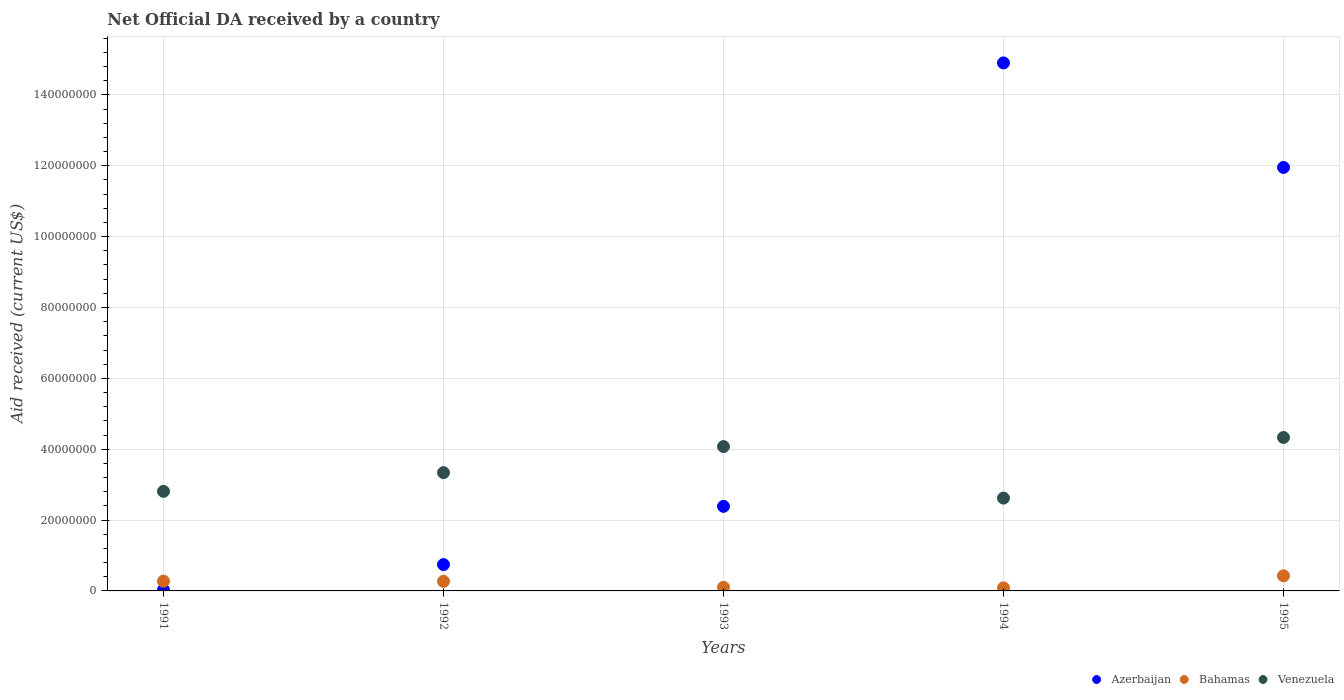How many different coloured dotlines are there?
Your answer should be very brief. 3. What is the net official development assistance aid received in Venezuela in 1992?
Make the answer very short. 3.34e+07. Across all years, what is the maximum net official development assistance aid received in Bahamas?
Offer a terse response. 4.26e+06. Across all years, what is the minimum net official development assistance aid received in Bahamas?
Keep it short and to the point. 8.70e+05. In which year was the net official development assistance aid received in Azerbaijan minimum?
Make the answer very short. 1991. What is the total net official development assistance aid received in Venezuela in the graph?
Make the answer very short. 1.72e+08. What is the difference between the net official development assistance aid received in Bahamas in 1992 and that in 1995?
Ensure brevity in your answer.  -1.56e+06. What is the difference between the net official development assistance aid received in Azerbaijan in 1991 and the net official development assistance aid received in Bahamas in 1992?
Give a very brief answer. -2.40e+06. What is the average net official development assistance aid received in Azerbaijan per year?
Make the answer very short. 6.00e+07. In the year 1994, what is the difference between the net official development assistance aid received in Bahamas and net official development assistance aid received in Azerbaijan?
Provide a short and direct response. -1.48e+08. What is the ratio of the net official development assistance aid received in Venezuela in 1992 to that in 1993?
Provide a succinct answer. 0.82. Is the net official development assistance aid received in Bahamas in 1994 less than that in 1995?
Keep it short and to the point. Yes. Is the difference between the net official development assistance aid received in Bahamas in 1993 and 1995 greater than the difference between the net official development assistance aid received in Azerbaijan in 1993 and 1995?
Offer a terse response. Yes. What is the difference between the highest and the second highest net official development assistance aid received in Venezuela?
Keep it short and to the point. 2.57e+06. What is the difference between the highest and the lowest net official development assistance aid received in Bahamas?
Your answer should be very brief. 3.39e+06. In how many years, is the net official development assistance aid received in Azerbaijan greater than the average net official development assistance aid received in Azerbaijan taken over all years?
Offer a terse response. 2. Is the sum of the net official development assistance aid received in Bahamas in 1993 and 1994 greater than the maximum net official development assistance aid received in Venezuela across all years?
Offer a terse response. No. Is it the case that in every year, the sum of the net official development assistance aid received in Azerbaijan and net official development assistance aid received in Bahamas  is greater than the net official development assistance aid received in Venezuela?
Offer a terse response. No. Is the net official development assistance aid received in Bahamas strictly less than the net official development assistance aid received in Azerbaijan over the years?
Provide a short and direct response. No. What is the difference between two consecutive major ticks on the Y-axis?
Make the answer very short. 2.00e+07. Does the graph contain any zero values?
Provide a short and direct response. No. Does the graph contain grids?
Your response must be concise. Yes. How are the legend labels stacked?
Keep it short and to the point. Horizontal. What is the title of the graph?
Offer a terse response. Net Official DA received by a country. What is the label or title of the X-axis?
Your response must be concise. Years. What is the label or title of the Y-axis?
Give a very brief answer. Aid received (current US$). What is the Aid received (current US$) in Bahamas in 1991?
Offer a very short reply. 2.76e+06. What is the Aid received (current US$) in Venezuela in 1991?
Provide a succinct answer. 2.81e+07. What is the Aid received (current US$) of Azerbaijan in 1992?
Offer a terse response. 7.43e+06. What is the Aid received (current US$) of Bahamas in 1992?
Your response must be concise. 2.70e+06. What is the Aid received (current US$) of Venezuela in 1992?
Your answer should be very brief. 3.34e+07. What is the Aid received (current US$) in Azerbaijan in 1993?
Provide a short and direct response. 2.39e+07. What is the Aid received (current US$) in Bahamas in 1993?
Your response must be concise. 1.03e+06. What is the Aid received (current US$) of Venezuela in 1993?
Your response must be concise. 4.08e+07. What is the Aid received (current US$) of Azerbaijan in 1994?
Your answer should be compact. 1.49e+08. What is the Aid received (current US$) in Bahamas in 1994?
Provide a succinct answer. 8.70e+05. What is the Aid received (current US$) of Venezuela in 1994?
Offer a very short reply. 2.62e+07. What is the Aid received (current US$) of Azerbaijan in 1995?
Your answer should be very brief. 1.20e+08. What is the Aid received (current US$) of Bahamas in 1995?
Ensure brevity in your answer.  4.26e+06. What is the Aid received (current US$) in Venezuela in 1995?
Your answer should be compact. 4.33e+07. Across all years, what is the maximum Aid received (current US$) in Azerbaijan?
Your answer should be compact. 1.49e+08. Across all years, what is the maximum Aid received (current US$) of Bahamas?
Keep it short and to the point. 4.26e+06. Across all years, what is the maximum Aid received (current US$) in Venezuela?
Your answer should be compact. 4.33e+07. Across all years, what is the minimum Aid received (current US$) of Azerbaijan?
Give a very brief answer. 3.00e+05. Across all years, what is the minimum Aid received (current US$) in Bahamas?
Your answer should be very brief. 8.70e+05. Across all years, what is the minimum Aid received (current US$) in Venezuela?
Provide a short and direct response. 2.62e+07. What is the total Aid received (current US$) in Azerbaijan in the graph?
Your response must be concise. 3.00e+08. What is the total Aid received (current US$) of Bahamas in the graph?
Ensure brevity in your answer.  1.16e+07. What is the total Aid received (current US$) of Venezuela in the graph?
Ensure brevity in your answer.  1.72e+08. What is the difference between the Aid received (current US$) in Azerbaijan in 1991 and that in 1992?
Offer a very short reply. -7.13e+06. What is the difference between the Aid received (current US$) in Venezuela in 1991 and that in 1992?
Ensure brevity in your answer.  -5.28e+06. What is the difference between the Aid received (current US$) of Azerbaijan in 1991 and that in 1993?
Your response must be concise. -2.36e+07. What is the difference between the Aid received (current US$) of Bahamas in 1991 and that in 1993?
Offer a terse response. 1.73e+06. What is the difference between the Aid received (current US$) of Venezuela in 1991 and that in 1993?
Provide a succinct answer. -1.26e+07. What is the difference between the Aid received (current US$) of Azerbaijan in 1991 and that in 1994?
Offer a terse response. -1.49e+08. What is the difference between the Aid received (current US$) of Bahamas in 1991 and that in 1994?
Offer a very short reply. 1.89e+06. What is the difference between the Aid received (current US$) of Venezuela in 1991 and that in 1994?
Offer a very short reply. 1.91e+06. What is the difference between the Aid received (current US$) of Azerbaijan in 1991 and that in 1995?
Your answer should be compact. -1.19e+08. What is the difference between the Aid received (current US$) of Bahamas in 1991 and that in 1995?
Give a very brief answer. -1.50e+06. What is the difference between the Aid received (current US$) in Venezuela in 1991 and that in 1995?
Provide a succinct answer. -1.52e+07. What is the difference between the Aid received (current US$) of Azerbaijan in 1992 and that in 1993?
Your answer should be compact. -1.64e+07. What is the difference between the Aid received (current US$) of Bahamas in 1992 and that in 1993?
Offer a terse response. 1.67e+06. What is the difference between the Aid received (current US$) in Venezuela in 1992 and that in 1993?
Provide a succinct answer. -7.36e+06. What is the difference between the Aid received (current US$) of Azerbaijan in 1992 and that in 1994?
Offer a very short reply. -1.42e+08. What is the difference between the Aid received (current US$) in Bahamas in 1992 and that in 1994?
Your answer should be compact. 1.83e+06. What is the difference between the Aid received (current US$) of Venezuela in 1992 and that in 1994?
Offer a very short reply. 7.19e+06. What is the difference between the Aid received (current US$) in Azerbaijan in 1992 and that in 1995?
Ensure brevity in your answer.  -1.12e+08. What is the difference between the Aid received (current US$) of Bahamas in 1992 and that in 1995?
Offer a very short reply. -1.56e+06. What is the difference between the Aid received (current US$) in Venezuela in 1992 and that in 1995?
Make the answer very short. -9.93e+06. What is the difference between the Aid received (current US$) in Azerbaijan in 1993 and that in 1994?
Your answer should be very brief. -1.25e+08. What is the difference between the Aid received (current US$) of Venezuela in 1993 and that in 1994?
Provide a succinct answer. 1.46e+07. What is the difference between the Aid received (current US$) of Azerbaijan in 1993 and that in 1995?
Your response must be concise. -9.57e+07. What is the difference between the Aid received (current US$) in Bahamas in 1993 and that in 1995?
Offer a terse response. -3.23e+06. What is the difference between the Aid received (current US$) in Venezuela in 1993 and that in 1995?
Provide a succinct answer. -2.57e+06. What is the difference between the Aid received (current US$) of Azerbaijan in 1994 and that in 1995?
Offer a terse response. 2.95e+07. What is the difference between the Aid received (current US$) in Bahamas in 1994 and that in 1995?
Your answer should be very brief. -3.39e+06. What is the difference between the Aid received (current US$) of Venezuela in 1994 and that in 1995?
Offer a terse response. -1.71e+07. What is the difference between the Aid received (current US$) in Azerbaijan in 1991 and the Aid received (current US$) in Bahamas in 1992?
Offer a terse response. -2.40e+06. What is the difference between the Aid received (current US$) in Azerbaijan in 1991 and the Aid received (current US$) in Venezuela in 1992?
Your answer should be very brief. -3.31e+07. What is the difference between the Aid received (current US$) in Bahamas in 1991 and the Aid received (current US$) in Venezuela in 1992?
Give a very brief answer. -3.06e+07. What is the difference between the Aid received (current US$) in Azerbaijan in 1991 and the Aid received (current US$) in Bahamas in 1993?
Give a very brief answer. -7.30e+05. What is the difference between the Aid received (current US$) of Azerbaijan in 1991 and the Aid received (current US$) of Venezuela in 1993?
Keep it short and to the point. -4.04e+07. What is the difference between the Aid received (current US$) of Bahamas in 1991 and the Aid received (current US$) of Venezuela in 1993?
Provide a succinct answer. -3.80e+07. What is the difference between the Aid received (current US$) of Azerbaijan in 1991 and the Aid received (current US$) of Bahamas in 1994?
Ensure brevity in your answer.  -5.70e+05. What is the difference between the Aid received (current US$) of Azerbaijan in 1991 and the Aid received (current US$) of Venezuela in 1994?
Provide a succinct answer. -2.59e+07. What is the difference between the Aid received (current US$) in Bahamas in 1991 and the Aid received (current US$) in Venezuela in 1994?
Your answer should be very brief. -2.34e+07. What is the difference between the Aid received (current US$) of Azerbaijan in 1991 and the Aid received (current US$) of Bahamas in 1995?
Provide a short and direct response. -3.96e+06. What is the difference between the Aid received (current US$) of Azerbaijan in 1991 and the Aid received (current US$) of Venezuela in 1995?
Your answer should be compact. -4.30e+07. What is the difference between the Aid received (current US$) of Bahamas in 1991 and the Aid received (current US$) of Venezuela in 1995?
Provide a short and direct response. -4.06e+07. What is the difference between the Aid received (current US$) of Azerbaijan in 1992 and the Aid received (current US$) of Bahamas in 1993?
Your response must be concise. 6.40e+06. What is the difference between the Aid received (current US$) in Azerbaijan in 1992 and the Aid received (current US$) in Venezuela in 1993?
Your response must be concise. -3.33e+07. What is the difference between the Aid received (current US$) in Bahamas in 1992 and the Aid received (current US$) in Venezuela in 1993?
Give a very brief answer. -3.80e+07. What is the difference between the Aid received (current US$) in Azerbaijan in 1992 and the Aid received (current US$) in Bahamas in 1994?
Your response must be concise. 6.56e+06. What is the difference between the Aid received (current US$) in Azerbaijan in 1992 and the Aid received (current US$) in Venezuela in 1994?
Your answer should be compact. -1.88e+07. What is the difference between the Aid received (current US$) of Bahamas in 1992 and the Aid received (current US$) of Venezuela in 1994?
Provide a short and direct response. -2.35e+07. What is the difference between the Aid received (current US$) in Azerbaijan in 1992 and the Aid received (current US$) in Bahamas in 1995?
Give a very brief answer. 3.17e+06. What is the difference between the Aid received (current US$) in Azerbaijan in 1992 and the Aid received (current US$) in Venezuela in 1995?
Provide a succinct answer. -3.59e+07. What is the difference between the Aid received (current US$) of Bahamas in 1992 and the Aid received (current US$) of Venezuela in 1995?
Ensure brevity in your answer.  -4.06e+07. What is the difference between the Aid received (current US$) in Azerbaijan in 1993 and the Aid received (current US$) in Bahamas in 1994?
Make the answer very short. 2.30e+07. What is the difference between the Aid received (current US$) of Azerbaijan in 1993 and the Aid received (current US$) of Venezuela in 1994?
Keep it short and to the point. -2.33e+06. What is the difference between the Aid received (current US$) of Bahamas in 1993 and the Aid received (current US$) of Venezuela in 1994?
Your answer should be very brief. -2.52e+07. What is the difference between the Aid received (current US$) of Azerbaijan in 1993 and the Aid received (current US$) of Bahamas in 1995?
Provide a succinct answer. 1.96e+07. What is the difference between the Aid received (current US$) of Azerbaijan in 1993 and the Aid received (current US$) of Venezuela in 1995?
Ensure brevity in your answer.  -1.94e+07. What is the difference between the Aid received (current US$) of Bahamas in 1993 and the Aid received (current US$) of Venezuela in 1995?
Your response must be concise. -4.23e+07. What is the difference between the Aid received (current US$) in Azerbaijan in 1994 and the Aid received (current US$) in Bahamas in 1995?
Your response must be concise. 1.45e+08. What is the difference between the Aid received (current US$) in Azerbaijan in 1994 and the Aid received (current US$) in Venezuela in 1995?
Make the answer very short. 1.06e+08. What is the difference between the Aid received (current US$) of Bahamas in 1994 and the Aid received (current US$) of Venezuela in 1995?
Your answer should be compact. -4.24e+07. What is the average Aid received (current US$) of Azerbaijan per year?
Give a very brief answer. 6.00e+07. What is the average Aid received (current US$) of Bahamas per year?
Your answer should be compact. 2.32e+06. What is the average Aid received (current US$) in Venezuela per year?
Provide a succinct answer. 3.44e+07. In the year 1991, what is the difference between the Aid received (current US$) in Azerbaijan and Aid received (current US$) in Bahamas?
Provide a succinct answer. -2.46e+06. In the year 1991, what is the difference between the Aid received (current US$) in Azerbaijan and Aid received (current US$) in Venezuela?
Offer a very short reply. -2.78e+07. In the year 1991, what is the difference between the Aid received (current US$) in Bahamas and Aid received (current US$) in Venezuela?
Offer a terse response. -2.54e+07. In the year 1992, what is the difference between the Aid received (current US$) in Azerbaijan and Aid received (current US$) in Bahamas?
Your response must be concise. 4.73e+06. In the year 1992, what is the difference between the Aid received (current US$) in Azerbaijan and Aid received (current US$) in Venezuela?
Keep it short and to the point. -2.60e+07. In the year 1992, what is the difference between the Aid received (current US$) in Bahamas and Aid received (current US$) in Venezuela?
Give a very brief answer. -3.07e+07. In the year 1993, what is the difference between the Aid received (current US$) of Azerbaijan and Aid received (current US$) of Bahamas?
Your answer should be compact. 2.28e+07. In the year 1993, what is the difference between the Aid received (current US$) in Azerbaijan and Aid received (current US$) in Venezuela?
Ensure brevity in your answer.  -1.69e+07. In the year 1993, what is the difference between the Aid received (current US$) in Bahamas and Aid received (current US$) in Venezuela?
Offer a terse response. -3.97e+07. In the year 1994, what is the difference between the Aid received (current US$) in Azerbaijan and Aid received (current US$) in Bahamas?
Offer a very short reply. 1.48e+08. In the year 1994, what is the difference between the Aid received (current US$) in Azerbaijan and Aid received (current US$) in Venezuela?
Provide a succinct answer. 1.23e+08. In the year 1994, what is the difference between the Aid received (current US$) of Bahamas and Aid received (current US$) of Venezuela?
Your answer should be compact. -2.53e+07. In the year 1995, what is the difference between the Aid received (current US$) of Azerbaijan and Aid received (current US$) of Bahamas?
Provide a short and direct response. 1.15e+08. In the year 1995, what is the difference between the Aid received (current US$) in Azerbaijan and Aid received (current US$) in Venezuela?
Offer a terse response. 7.62e+07. In the year 1995, what is the difference between the Aid received (current US$) in Bahamas and Aid received (current US$) in Venezuela?
Provide a succinct answer. -3.91e+07. What is the ratio of the Aid received (current US$) in Azerbaijan in 1991 to that in 1992?
Offer a very short reply. 0.04. What is the ratio of the Aid received (current US$) of Bahamas in 1991 to that in 1992?
Ensure brevity in your answer.  1.02. What is the ratio of the Aid received (current US$) of Venezuela in 1991 to that in 1992?
Your answer should be very brief. 0.84. What is the ratio of the Aid received (current US$) of Azerbaijan in 1991 to that in 1993?
Offer a terse response. 0.01. What is the ratio of the Aid received (current US$) of Bahamas in 1991 to that in 1993?
Make the answer very short. 2.68. What is the ratio of the Aid received (current US$) of Venezuela in 1991 to that in 1993?
Give a very brief answer. 0.69. What is the ratio of the Aid received (current US$) in Azerbaijan in 1991 to that in 1994?
Make the answer very short. 0. What is the ratio of the Aid received (current US$) of Bahamas in 1991 to that in 1994?
Make the answer very short. 3.17. What is the ratio of the Aid received (current US$) in Venezuela in 1991 to that in 1994?
Ensure brevity in your answer.  1.07. What is the ratio of the Aid received (current US$) of Azerbaijan in 1991 to that in 1995?
Make the answer very short. 0. What is the ratio of the Aid received (current US$) of Bahamas in 1991 to that in 1995?
Make the answer very short. 0.65. What is the ratio of the Aid received (current US$) of Venezuela in 1991 to that in 1995?
Ensure brevity in your answer.  0.65. What is the ratio of the Aid received (current US$) of Azerbaijan in 1992 to that in 1993?
Provide a short and direct response. 0.31. What is the ratio of the Aid received (current US$) of Bahamas in 1992 to that in 1993?
Your response must be concise. 2.62. What is the ratio of the Aid received (current US$) in Venezuela in 1992 to that in 1993?
Keep it short and to the point. 0.82. What is the ratio of the Aid received (current US$) of Azerbaijan in 1992 to that in 1994?
Provide a short and direct response. 0.05. What is the ratio of the Aid received (current US$) of Bahamas in 1992 to that in 1994?
Ensure brevity in your answer.  3.1. What is the ratio of the Aid received (current US$) in Venezuela in 1992 to that in 1994?
Your answer should be compact. 1.27. What is the ratio of the Aid received (current US$) of Azerbaijan in 1992 to that in 1995?
Provide a short and direct response. 0.06. What is the ratio of the Aid received (current US$) of Bahamas in 1992 to that in 1995?
Keep it short and to the point. 0.63. What is the ratio of the Aid received (current US$) of Venezuela in 1992 to that in 1995?
Your answer should be compact. 0.77. What is the ratio of the Aid received (current US$) in Azerbaijan in 1993 to that in 1994?
Offer a terse response. 0.16. What is the ratio of the Aid received (current US$) in Bahamas in 1993 to that in 1994?
Your answer should be very brief. 1.18. What is the ratio of the Aid received (current US$) in Venezuela in 1993 to that in 1994?
Your answer should be compact. 1.56. What is the ratio of the Aid received (current US$) in Azerbaijan in 1993 to that in 1995?
Give a very brief answer. 0.2. What is the ratio of the Aid received (current US$) in Bahamas in 1993 to that in 1995?
Provide a short and direct response. 0.24. What is the ratio of the Aid received (current US$) in Venezuela in 1993 to that in 1995?
Provide a short and direct response. 0.94. What is the ratio of the Aid received (current US$) in Azerbaijan in 1994 to that in 1995?
Your answer should be very brief. 1.25. What is the ratio of the Aid received (current US$) in Bahamas in 1994 to that in 1995?
Provide a succinct answer. 0.2. What is the ratio of the Aid received (current US$) of Venezuela in 1994 to that in 1995?
Your answer should be very brief. 0.6. What is the difference between the highest and the second highest Aid received (current US$) in Azerbaijan?
Offer a terse response. 2.95e+07. What is the difference between the highest and the second highest Aid received (current US$) in Bahamas?
Your response must be concise. 1.50e+06. What is the difference between the highest and the second highest Aid received (current US$) in Venezuela?
Give a very brief answer. 2.57e+06. What is the difference between the highest and the lowest Aid received (current US$) in Azerbaijan?
Provide a short and direct response. 1.49e+08. What is the difference between the highest and the lowest Aid received (current US$) in Bahamas?
Offer a terse response. 3.39e+06. What is the difference between the highest and the lowest Aid received (current US$) of Venezuela?
Your answer should be very brief. 1.71e+07. 